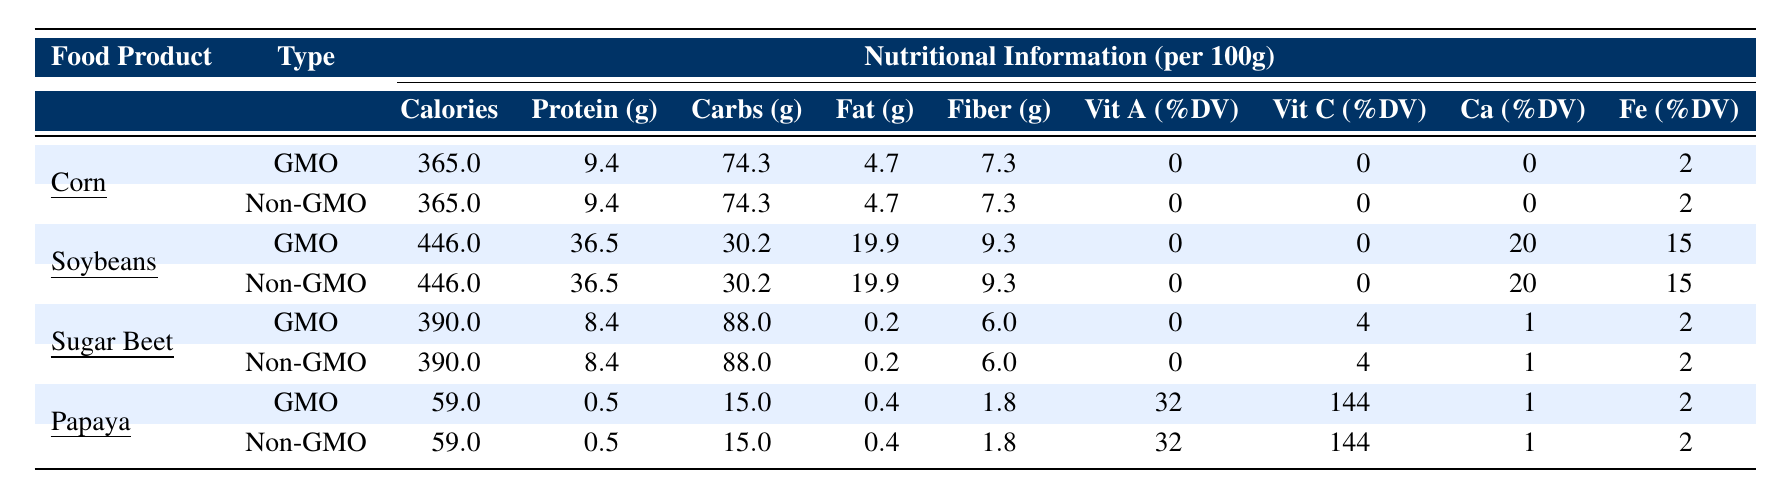What is the calorie content of GMO corn? The table shows that the calorie content of GMO corn is listed under the "Calories" column for GMO corn, which is 365.
Answer: 365 What is the protein content in non-GMO soybeans? The table displays the protein content in non-GMO soybeans under the "Protein (g)" column, which is 36.5 grams.
Answer: 36.5 g Is the fat content in GMO papaya higher than in non-GMO papaya? The table lists the fat content for both GMO and non-GMO papaya, which is 0.4 grams for both types, indicating they are equal.
Answer: No What is the difference in fiber content between GMO and non-GMO sugar beet? The table indicates that both GMO and non-GMO sugar beet have the same fiber content of 6.0 grams, so the difference is 0 grams.
Answer: 0 g Which food product has the highest protein content per 100g? Comparing the protein content in the table, soybeans (both GMO and non-GMO) have the highest protein content at 36.5 grams.
Answer: Soybeans What is the total carbohydrate content in GMO corn and GMO papaya combined? The table shows GMO corn has 74.3 grams of carbohydrates, and GMO papaya has 15 grams. Adding these together gives 74.3 + 15 = 89.3 grams.
Answer: 89.3 g Are vitamin A and vitamin C content the same for GMO and non-GMO corn? The table lists the vitamin A and C content for both types of corn as 0% DV for vitamin A and 0% DV for vitamin C, so they are indeed the same.
Answer: Yes What is the average fiber content across all food products listed? The fiber content for each product is 7.3 (corn), 9.3 (soybeans), 6.0 (sugar beet), and 1.8 (papaya). Adding these gives 24.4 grams, and dividing by the 4 products results in an average of 24.4 / 4 = 6.1 grams.
Answer: 6.1 g Which food product shows the highest percentage of vitamin C in the GMO category? The table lists GMO papaya with Vit C %DV of 144, which is higher than any other GMO product listed.
Answer: Papaya If a consumer is focused on iron content, which food should they choose? The table lists soybean and non-GMO soybeans with 15% DV iron content, which is the highest compared to other products.
Answer: Soybeans 